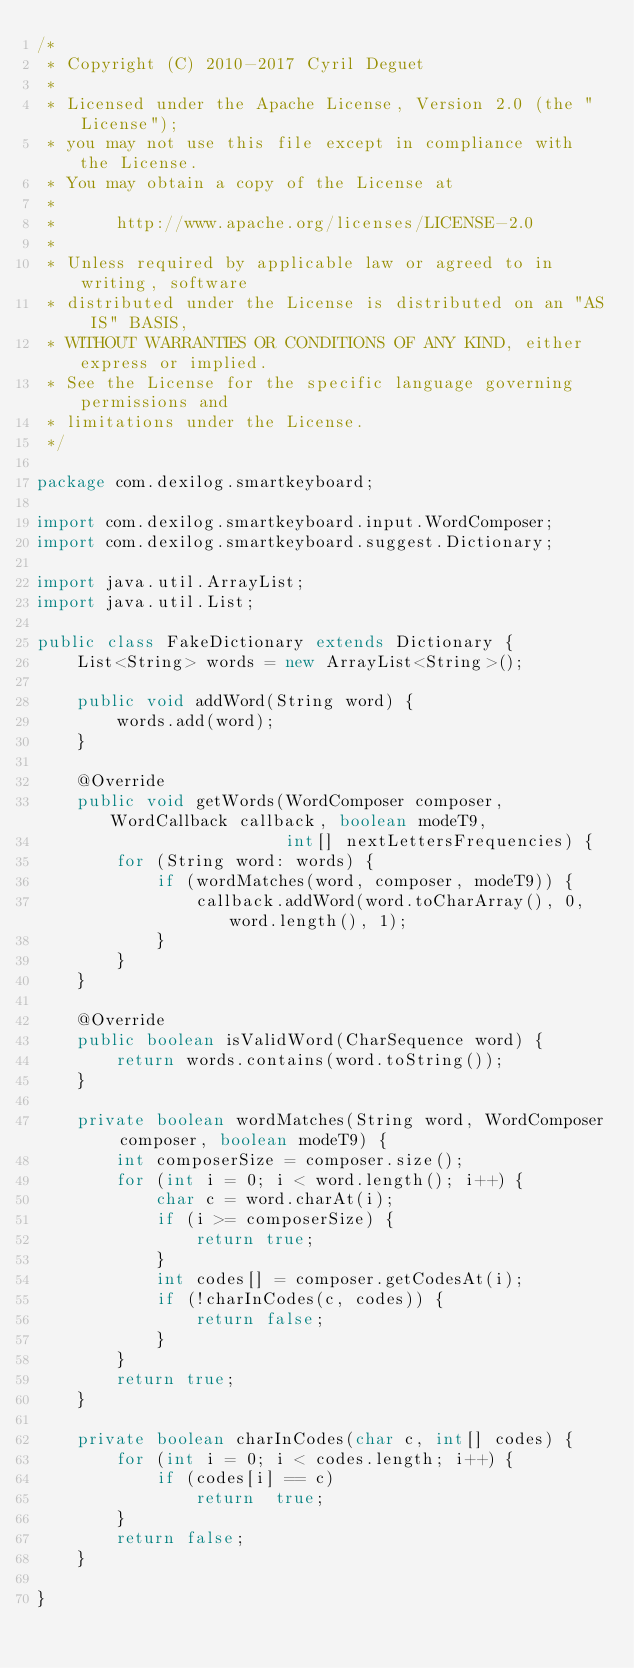Convert code to text. <code><loc_0><loc_0><loc_500><loc_500><_Java_>/*
 * Copyright (C) 2010-2017 Cyril Deguet
 *
 * Licensed under the Apache License, Version 2.0 (the "License");
 * you may not use this file except in compliance with the License.
 * You may obtain a copy of the License at
 *
 *      http://www.apache.org/licenses/LICENSE-2.0
 *
 * Unless required by applicable law or agreed to in writing, software
 * distributed under the License is distributed on an "AS IS" BASIS,
 * WITHOUT WARRANTIES OR CONDITIONS OF ANY KIND, either express or implied.
 * See the License for the specific language governing permissions and
 * limitations under the License.
 */

package com.dexilog.smartkeyboard;

import com.dexilog.smartkeyboard.input.WordComposer;
import com.dexilog.smartkeyboard.suggest.Dictionary;

import java.util.ArrayList;
import java.util.List;

public class FakeDictionary extends Dictionary {
    List<String> words = new ArrayList<String>();

    public void addWord(String word) {
        words.add(word);
    }

    @Override
    public void getWords(WordComposer composer, WordCallback callback, boolean modeT9,
                         int[] nextLettersFrequencies) {
        for (String word: words) {
            if (wordMatches(word, composer, modeT9)) {
                callback.addWord(word.toCharArray(), 0, word.length(), 1);
            }
        }
    }

    @Override
    public boolean isValidWord(CharSequence word) {
        return words.contains(word.toString());
    }

    private boolean wordMatches(String word, WordComposer composer, boolean modeT9) {
        int composerSize = composer.size();
        for (int i = 0; i < word.length(); i++) {
            char c = word.charAt(i);
            if (i >= composerSize) {
                return true;
            }
            int codes[] = composer.getCodesAt(i);
            if (!charInCodes(c, codes)) {
                return false;
            }
        }
        return true;
    }

    private boolean charInCodes(char c, int[] codes) {
        for (int i = 0; i < codes.length; i++) {
            if (codes[i] == c)
                return  true;
        }
        return false;
    }

}
</code> 